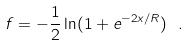Convert formula to latex. <formula><loc_0><loc_0><loc_500><loc_500>f = - \frac { 1 } { 2 } \ln ( 1 + e ^ { - 2 x / R } ) \ .</formula> 